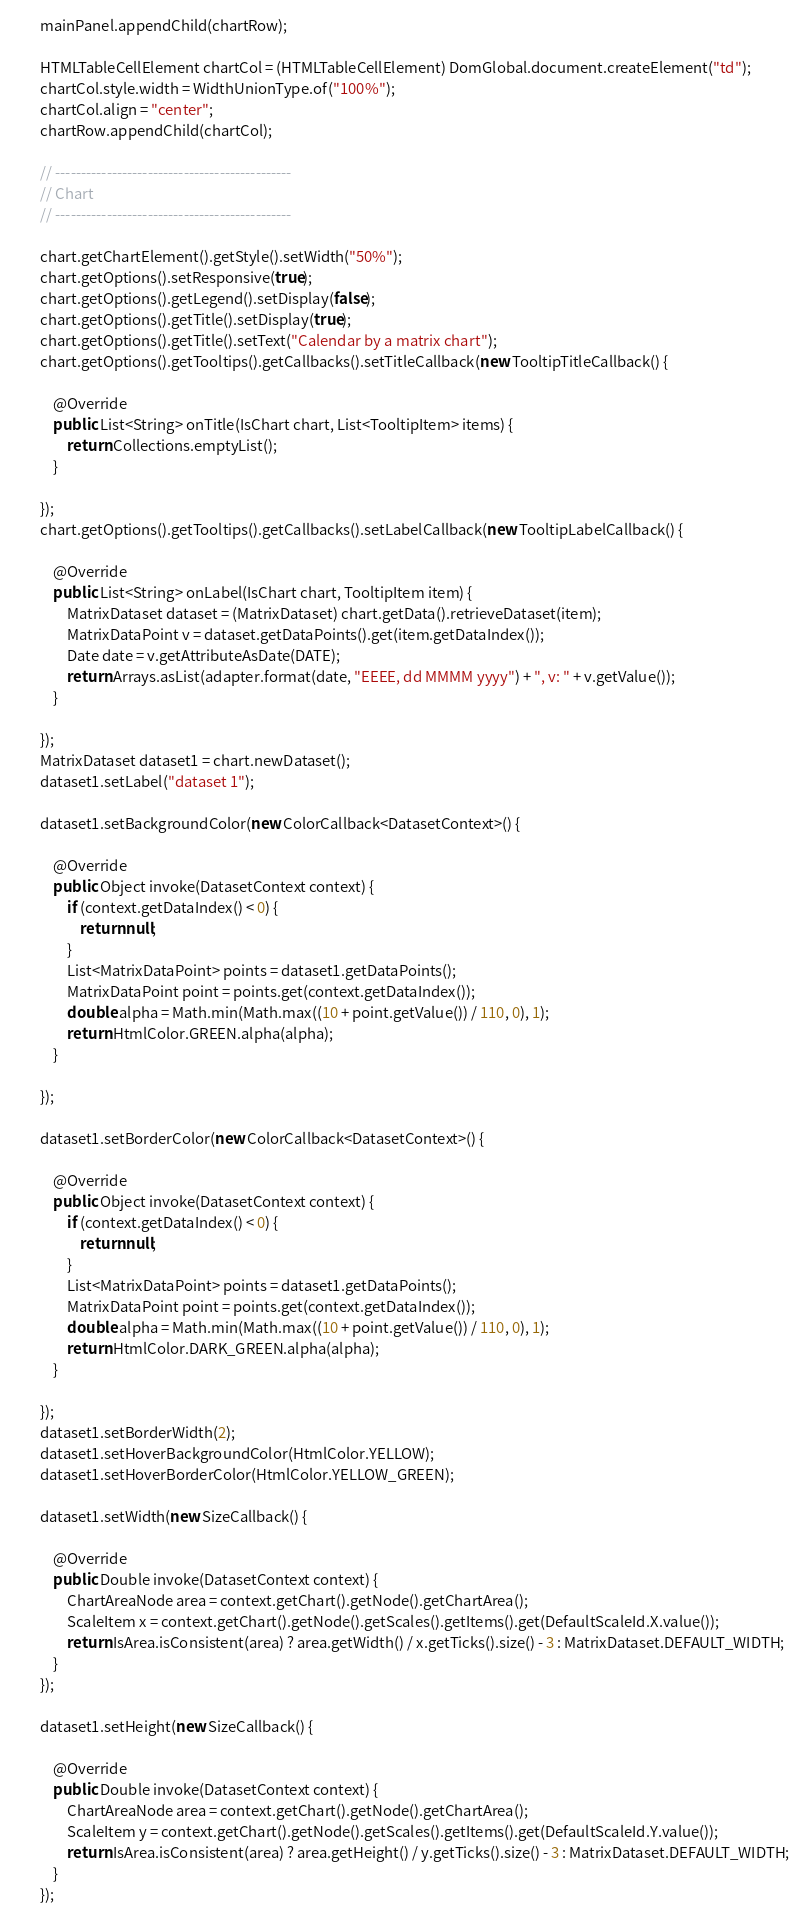<code> <loc_0><loc_0><loc_500><loc_500><_Java_>		mainPanel.appendChild(chartRow);

		HTMLTableCellElement chartCol = (HTMLTableCellElement) DomGlobal.document.createElement("td");
		chartCol.style.width = WidthUnionType.of("100%");
		chartCol.align = "center";
		chartRow.appendChild(chartCol);

		// ----------------------------------------------
		// Chart
		// ----------------------------------------------

		chart.getChartElement().getStyle().setWidth("50%");
		chart.getOptions().setResponsive(true);
		chart.getOptions().getLegend().setDisplay(false);
		chart.getOptions().getTitle().setDisplay(true);
		chart.getOptions().getTitle().setText("Calendar by a matrix chart");
		chart.getOptions().getTooltips().getCallbacks().setTitleCallback(new TooltipTitleCallback() {

			@Override
			public List<String> onTitle(IsChart chart, List<TooltipItem> items) {
				return Collections.emptyList();
			}

		});
		chart.getOptions().getTooltips().getCallbacks().setLabelCallback(new TooltipLabelCallback() {

			@Override
			public List<String> onLabel(IsChart chart, TooltipItem item) {
				MatrixDataset dataset = (MatrixDataset) chart.getData().retrieveDataset(item);
				MatrixDataPoint v = dataset.getDataPoints().get(item.getDataIndex());
				Date date = v.getAttributeAsDate(DATE);
				return Arrays.asList(adapter.format(date, "EEEE, dd MMMM yyyy") + ", v: " + v.getValue());
			}

		});
		MatrixDataset dataset1 = chart.newDataset();
		dataset1.setLabel("dataset 1");

		dataset1.setBackgroundColor(new ColorCallback<DatasetContext>() {

			@Override
			public Object invoke(DatasetContext context) {
				if (context.getDataIndex() < 0) {
					return null;
				}
				List<MatrixDataPoint> points = dataset1.getDataPoints();
				MatrixDataPoint point = points.get(context.getDataIndex());
				double alpha = Math.min(Math.max((10 + point.getValue()) / 110, 0), 1);
				return HtmlColor.GREEN.alpha(alpha);
			}

		});

		dataset1.setBorderColor(new ColorCallback<DatasetContext>() {

			@Override
			public Object invoke(DatasetContext context) {
				if (context.getDataIndex() < 0) {
					return null;
				}
				List<MatrixDataPoint> points = dataset1.getDataPoints();
				MatrixDataPoint point = points.get(context.getDataIndex());
				double alpha = Math.min(Math.max((10 + point.getValue()) / 110, 0), 1);
				return HtmlColor.DARK_GREEN.alpha(alpha);
			}

		});
		dataset1.setBorderWidth(2);
		dataset1.setHoverBackgroundColor(HtmlColor.YELLOW);
		dataset1.setHoverBorderColor(HtmlColor.YELLOW_GREEN);

		dataset1.setWidth(new SizeCallback() {

			@Override
			public Double invoke(DatasetContext context) {
				ChartAreaNode area = context.getChart().getNode().getChartArea();
				ScaleItem x = context.getChart().getNode().getScales().getItems().get(DefaultScaleId.X.value());
				return IsArea.isConsistent(area) ? area.getWidth() / x.getTicks().size() - 3 : MatrixDataset.DEFAULT_WIDTH;
			}
		});

		dataset1.setHeight(new SizeCallback() {

			@Override
			public Double invoke(DatasetContext context) {
				ChartAreaNode area = context.getChart().getNode().getChartArea();
				ScaleItem y = context.getChart().getNode().getScales().getItems().get(DefaultScaleId.Y.value());
				return IsArea.isConsistent(area) ? area.getHeight() / y.getTicks().size() - 3 : MatrixDataset.DEFAULT_WIDTH;
			}
		});
</code> 